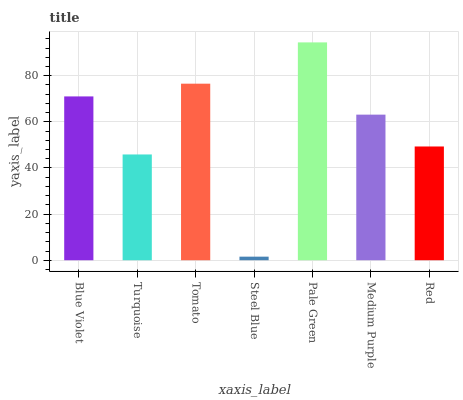Is Steel Blue the minimum?
Answer yes or no. Yes. Is Pale Green the maximum?
Answer yes or no. Yes. Is Turquoise the minimum?
Answer yes or no. No. Is Turquoise the maximum?
Answer yes or no. No. Is Blue Violet greater than Turquoise?
Answer yes or no. Yes. Is Turquoise less than Blue Violet?
Answer yes or no. Yes. Is Turquoise greater than Blue Violet?
Answer yes or no. No. Is Blue Violet less than Turquoise?
Answer yes or no. No. Is Medium Purple the high median?
Answer yes or no. Yes. Is Medium Purple the low median?
Answer yes or no. Yes. Is Blue Violet the high median?
Answer yes or no. No. Is Tomato the low median?
Answer yes or no. No. 